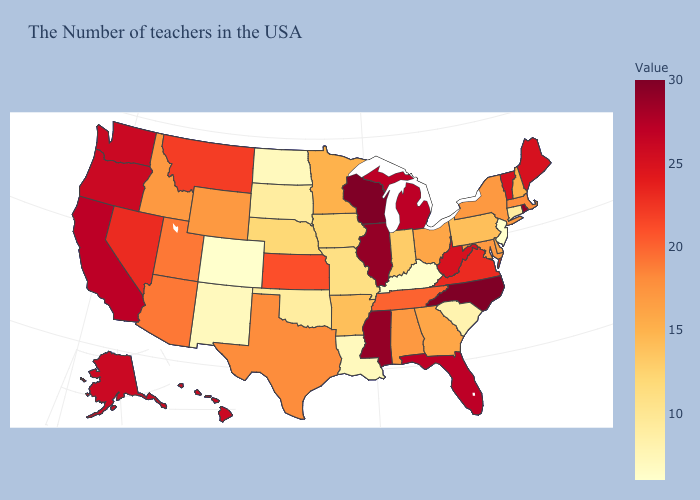Which states have the lowest value in the USA?
Concise answer only. New Jersey, Kentucky, Colorado. 